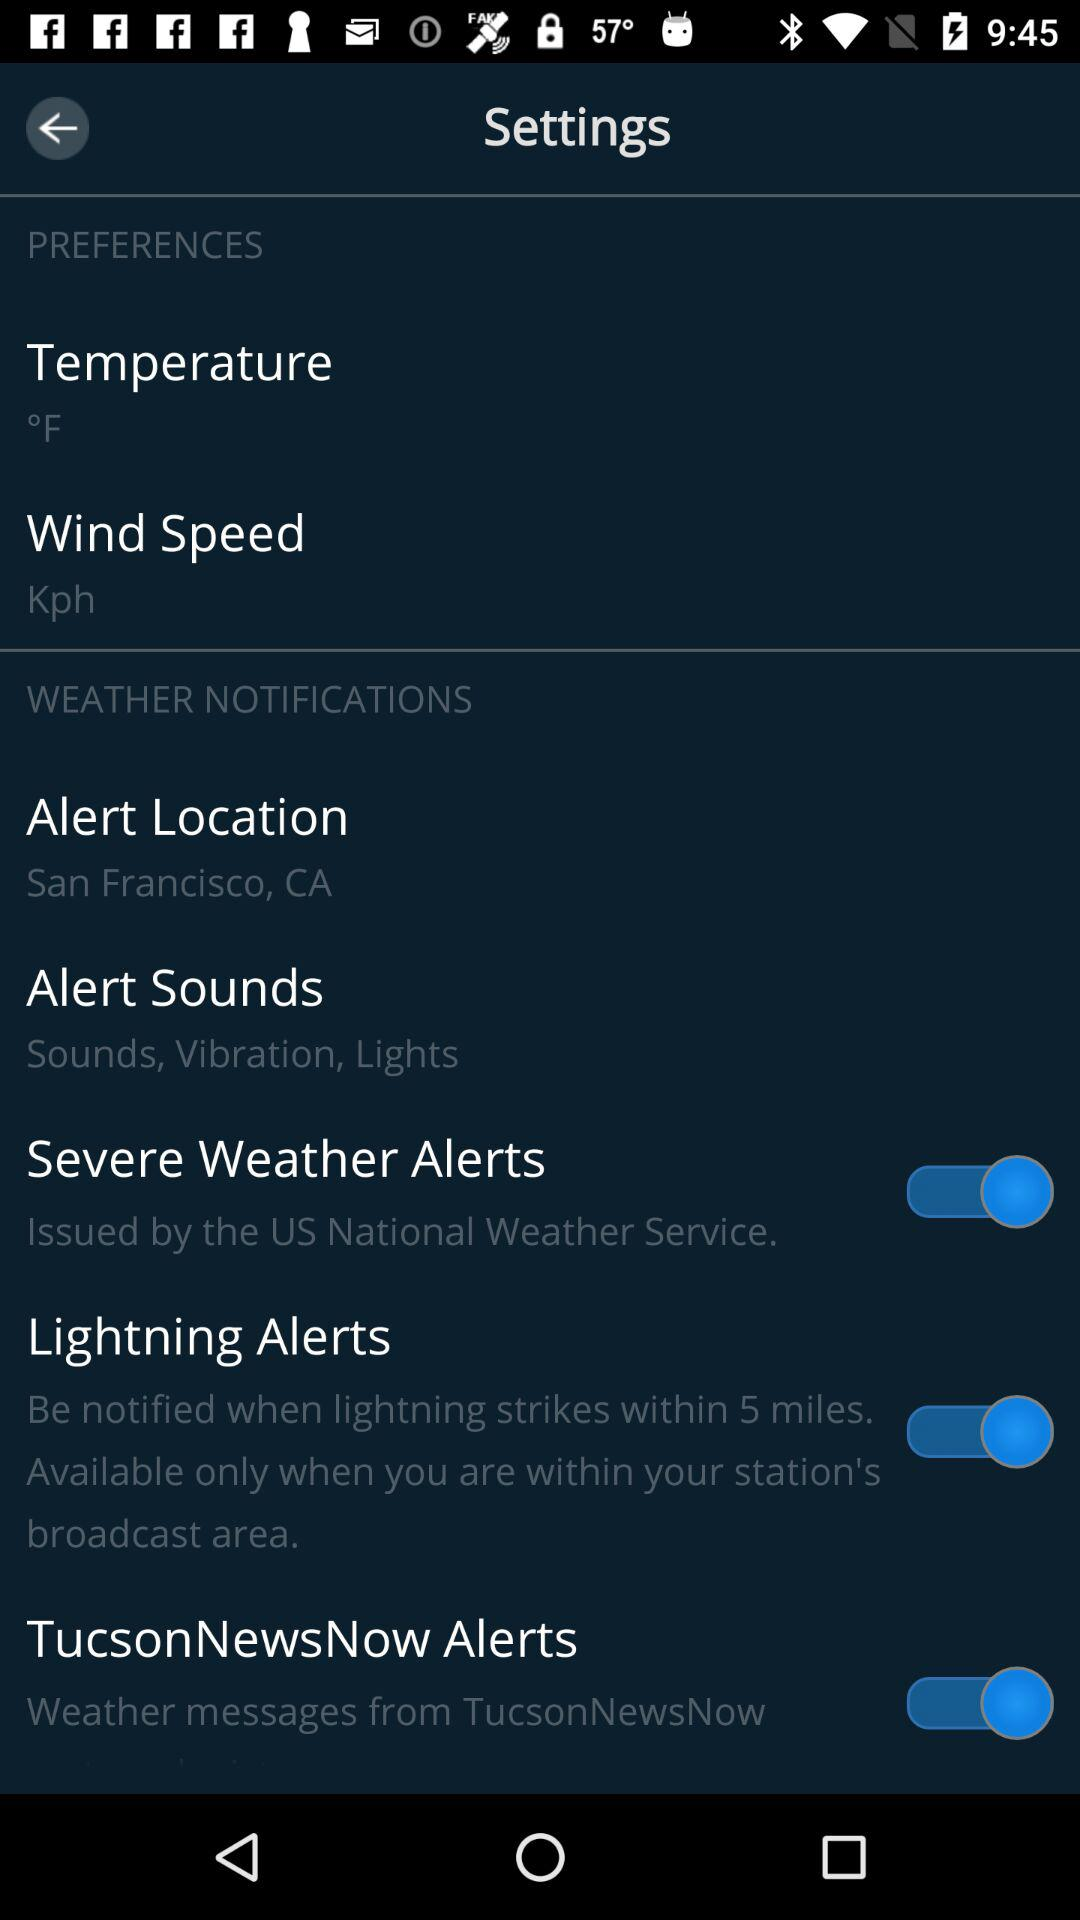What is the alert location? The alert location is San Francisco, CA. 